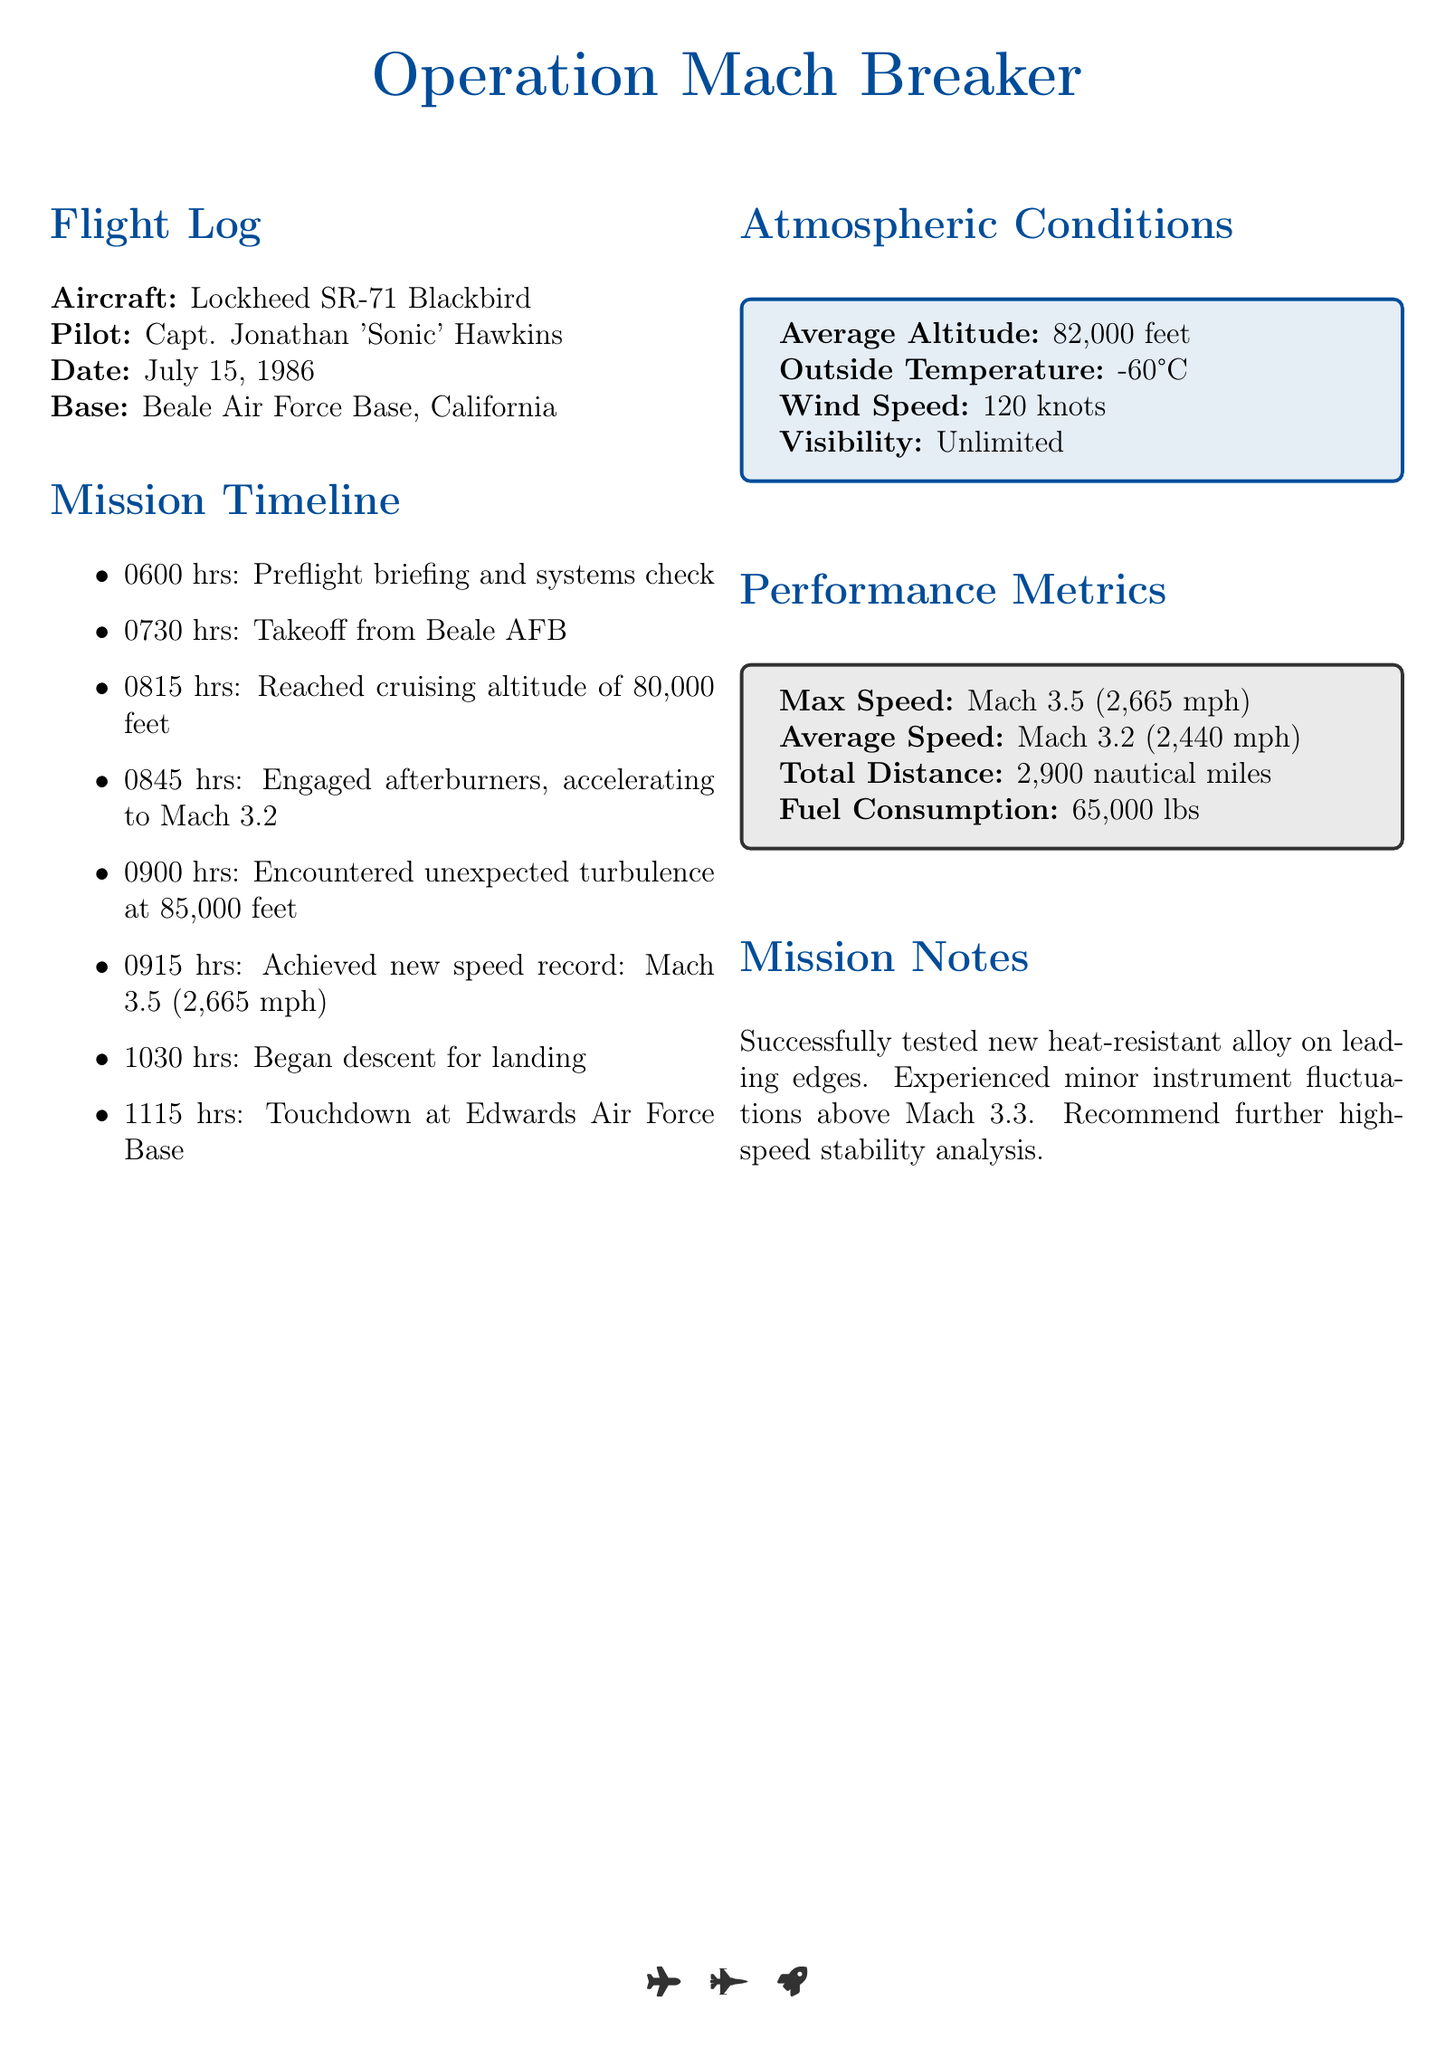what is the name of the pilot? The pilot's name is given as Capt. Jonathan 'Sonic' Hawkins in the document.
Answer: Capt. Jonathan 'Sonic' Hawkins what is the maximum speed achieved during the mission? The maximum speed achieved is mentioned in the Performance Metrics section as Mach 3.5 (2,665 mph).
Answer: Mach 3.5 (2,665 mph) what time did the aircraft reach cruising altitude? The time noted for reaching cruising altitude is specified in the Mission Timeline as 0815 hrs.
Answer: 0815 hrs what was the average altitude during the mission? The average altitude is indicated in the Atmospheric Conditions section as 82,000 feet.
Answer: 82,000 feet how many pounds of fuel were consumed? The fuel consumption is described in the Performance Metrics as 65,000 lbs.
Answer: 65,000 lbs what unexpected event occurred at 85,000 feet? The unexpected event noted is turbulence encountered at that altitude, as stated in the Mission Timeline.
Answer: turbulence what was the total distance traveled during the mission? The total distance is provided in the Performance Metrics as 2,900 nautical miles.
Answer: 2,900 nautical miles what temperature was recorded outside during the flight? The outside temperature is given in the Atmospheric Conditions section as -60°C.
Answer: -60°C what recommendation is made in the Mission Notes? The recommendation made is for further high-speed stability analysis, which is detailed in the Mission Notes section.
Answer: further high-speed stability analysis 